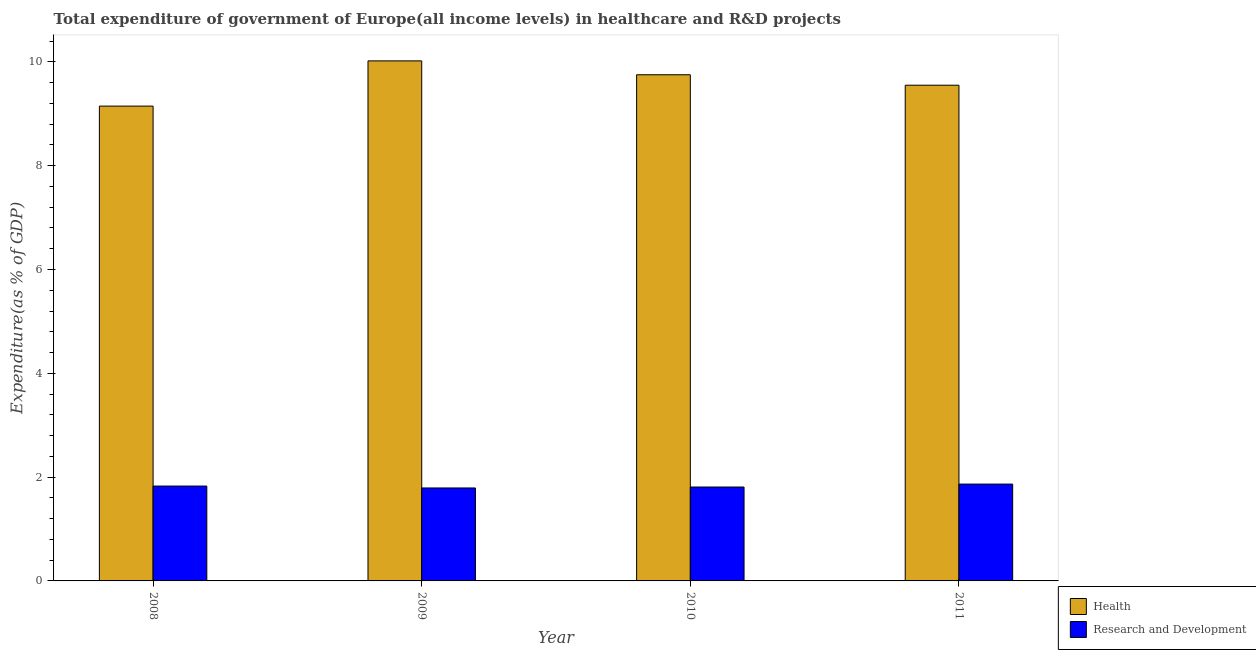How many different coloured bars are there?
Your answer should be very brief. 2. How many bars are there on the 2nd tick from the left?
Give a very brief answer. 2. What is the label of the 4th group of bars from the left?
Your answer should be compact. 2011. In how many cases, is the number of bars for a given year not equal to the number of legend labels?
Offer a terse response. 0. What is the expenditure in r&d in 2011?
Provide a short and direct response. 1.87. Across all years, what is the maximum expenditure in r&d?
Offer a terse response. 1.87. Across all years, what is the minimum expenditure in healthcare?
Keep it short and to the point. 9.15. In which year was the expenditure in healthcare minimum?
Keep it short and to the point. 2008. What is the total expenditure in healthcare in the graph?
Make the answer very short. 38.47. What is the difference between the expenditure in r&d in 2009 and that in 2011?
Keep it short and to the point. -0.07. What is the difference between the expenditure in r&d in 2009 and the expenditure in healthcare in 2008?
Make the answer very short. -0.04. What is the average expenditure in healthcare per year?
Keep it short and to the point. 9.62. In the year 2009, what is the difference between the expenditure in r&d and expenditure in healthcare?
Offer a very short reply. 0. In how many years, is the expenditure in r&d greater than 4.8 %?
Your answer should be compact. 0. What is the ratio of the expenditure in r&d in 2009 to that in 2011?
Your answer should be compact. 0.96. Is the difference between the expenditure in r&d in 2009 and 2010 greater than the difference between the expenditure in healthcare in 2009 and 2010?
Your response must be concise. No. What is the difference between the highest and the second highest expenditure in r&d?
Your response must be concise. 0.04. What is the difference between the highest and the lowest expenditure in healthcare?
Your response must be concise. 0.87. What does the 1st bar from the left in 2009 represents?
Provide a short and direct response. Health. What does the 2nd bar from the right in 2010 represents?
Offer a terse response. Health. What is the difference between two consecutive major ticks on the Y-axis?
Provide a succinct answer. 2. Where does the legend appear in the graph?
Offer a terse response. Bottom right. How are the legend labels stacked?
Provide a short and direct response. Vertical. What is the title of the graph?
Your answer should be very brief. Total expenditure of government of Europe(all income levels) in healthcare and R&D projects. Does "Male entrants" appear as one of the legend labels in the graph?
Keep it short and to the point. No. What is the label or title of the X-axis?
Offer a terse response. Year. What is the label or title of the Y-axis?
Your answer should be very brief. Expenditure(as % of GDP). What is the Expenditure(as % of GDP) in Health in 2008?
Provide a short and direct response. 9.15. What is the Expenditure(as % of GDP) of Research and Development in 2008?
Your answer should be compact. 1.83. What is the Expenditure(as % of GDP) of Health in 2009?
Your answer should be compact. 10.02. What is the Expenditure(as % of GDP) of Research and Development in 2009?
Offer a terse response. 1.79. What is the Expenditure(as % of GDP) of Health in 2010?
Your response must be concise. 9.75. What is the Expenditure(as % of GDP) of Research and Development in 2010?
Ensure brevity in your answer.  1.81. What is the Expenditure(as % of GDP) of Health in 2011?
Make the answer very short. 9.55. What is the Expenditure(as % of GDP) of Research and Development in 2011?
Make the answer very short. 1.87. Across all years, what is the maximum Expenditure(as % of GDP) in Health?
Your answer should be very brief. 10.02. Across all years, what is the maximum Expenditure(as % of GDP) in Research and Development?
Give a very brief answer. 1.87. Across all years, what is the minimum Expenditure(as % of GDP) of Health?
Offer a very short reply. 9.15. Across all years, what is the minimum Expenditure(as % of GDP) of Research and Development?
Give a very brief answer. 1.79. What is the total Expenditure(as % of GDP) in Health in the graph?
Your answer should be very brief. 38.47. What is the total Expenditure(as % of GDP) of Research and Development in the graph?
Ensure brevity in your answer.  7.29. What is the difference between the Expenditure(as % of GDP) in Health in 2008 and that in 2009?
Ensure brevity in your answer.  -0.87. What is the difference between the Expenditure(as % of GDP) in Research and Development in 2008 and that in 2009?
Keep it short and to the point. 0.04. What is the difference between the Expenditure(as % of GDP) in Health in 2008 and that in 2010?
Your answer should be very brief. -0.6. What is the difference between the Expenditure(as % of GDP) of Research and Development in 2008 and that in 2010?
Give a very brief answer. 0.02. What is the difference between the Expenditure(as % of GDP) in Health in 2008 and that in 2011?
Offer a very short reply. -0.4. What is the difference between the Expenditure(as % of GDP) of Research and Development in 2008 and that in 2011?
Offer a very short reply. -0.04. What is the difference between the Expenditure(as % of GDP) in Health in 2009 and that in 2010?
Make the answer very short. 0.27. What is the difference between the Expenditure(as % of GDP) of Research and Development in 2009 and that in 2010?
Provide a succinct answer. -0.02. What is the difference between the Expenditure(as % of GDP) of Health in 2009 and that in 2011?
Make the answer very short. 0.47. What is the difference between the Expenditure(as % of GDP) of Research and Development in 2009 and that in 2011?
Provide a succinct answer. -0.07. What is the difference between the Expenditure(as % of GDP) in Health in 2010 and that in 2011?
Give a very brief answer. 0.2. What is the difference between the Expenditure(as % of GDP) of Research and Development in 2010 and that in 2011?
Provide a succinct answer. -0.06. What is the difference between the Expenditure(as % of GDP) in Health in 2008 and the Expenditure(as % of GDP) in Research and Development in 2009?
Provide a succinct answer. 7.36. What is the difference between the Expenditure(as % of GDP) in Health in 2008 and the Expenditure(as % of GDP) in Research and Development in 2010?
Give a very brief answer. 7.34. What is the difference between the Expenditure(as % of GDP) in Health in 2008 and the Expenditure(as % of GDP) in Research and Development in 2011?
Offer a terse response. 7.28. What is the difference between the Expenditure(as % of GDP) of Health in 2009 and the Expenditure(as % of GDP) of Research and Development in 2010?
Ensure brevity in your answer.  8.21. What is the difference between the Expenditure(as % of GDP) in Health in 2009 and the Expenditure(as % of GDP) in Research and Development in 2011?
Keep it short and to the point. 8.15. What is the difference between the Expenditure(as % of GDP) of Health in 2010 and the Expenditure(as % of GDP) of Research and Development in 2011?
Ensure brevity in your answer.  7.89. What is the average Expenditure(as % of GDP) of Health per year?
Keep it short and to the point. 9.62. What is the average Expenditure(as % of GDP) in Research and Development per year?
Provide a short and direct response. 1.82. In the year 2008, what is the difference between the Expenditure(as % of GDP) in Health and Expenditure(as % of GDP) in Research and Development?
Provide a short and direct response. 7.32. In the year 2009, what is the difference between the Expenditure(as % of GDP) of Health and Expenditure(as % of GDP) of Research and Development?
Your response must be concise. 8.23. In the year 2010, what is the difference between the Expenditure(as % of GDP) in Health and Expenditure(as % of GDP) in Research and Development?
Provide a short and direct response. 7.94. In the year 2011, what is the difference between the Expenditure(as % of GDP) of Health and Expenditure(as % of GDP) of Research and Development?
Your answer should be compact. 7.68. What is the ratio of the Expenditure(as % of GDP) in Research and Development in 2008 to that in 2009?
Offer a very short reply. 1.02. What is the ratio of the Expenditure(as % of GDP) in Health in 2008 to that in 2010?
Your answer should be compact. 0.94. What is the ratio of the Expenditure(as % of GDP) of Research and Development in 2008 to that in 2010?
Give a very brief answer. 1.01. What is the ratio of the Expenditure(as % of GDP) in Health in 2008 to that in 2011?
Ensure brevity in your answer.  0.96. What is the ratio of the Expenditure(as % of GDP) of Research and Development in 2008 to that in 2011?
Offer a terse response. 0.98. What is the ratio of the Expenditure(as % of GDP) of Health in 2009 to that in 2010?
Your answer should be compact. 1.03. What is the ratio of the Expenditure(as % of GDP) of Research and Development in 2009 to that in 2010?
Provide a succinct answer. 0.99. What is the ratio of the Expenditure(as % of GDP) in Health in 2009 to that in 2011?
Your answer should be very brief. 1.05. What is the ratio of the Expenditure(as % of GDP) in Research and Development in 2009 to that in 2011?
Your answer should be very brief. 0.96. What is the ratio of the Expenditure(as % of GDP) in Health in 2010 to that in 2011?
Offer a very short reply. 1.02. What is the ratio of the Expenditure(as % of GDP) in Research and Development in 2010 to that in 2011?
Give a very brief answer. 0.97. What is the difference between the highest and the second highest Expenditure(as % of GDP) in Health?
Your answer should be compact. 0.27. What is the difference between the highest and the second highest Expenditure(as % of GDP) in Research and Development?
Your answer should be very brief. 0.04. What is the difference between the highest and the lowest Expenditure(as % of GDP) of Health?
Provide a short and direct response. 0.87. What is the difference between the highest and the lowest Expenditure(as % of GDP) in Research and Development?
Your answer should be compact. 0.07. 